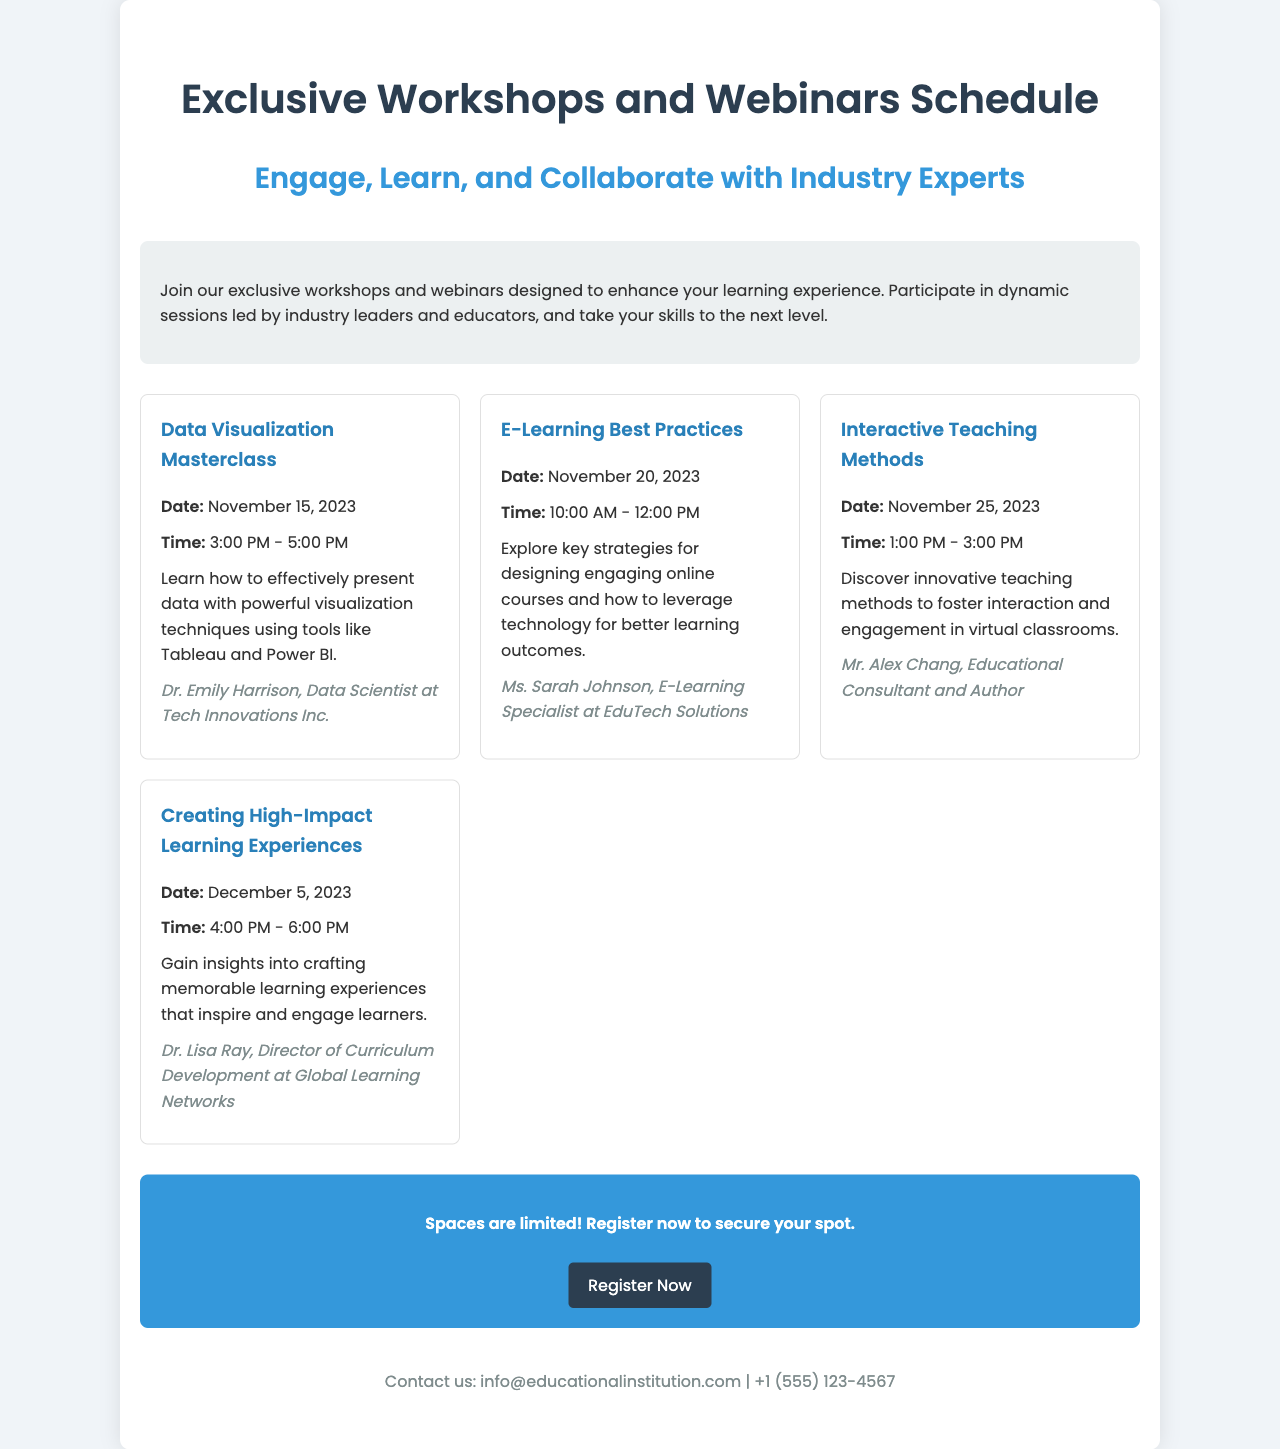What is the title of the brochure? The title of the brochure is prominently displayed at the top of the document, introducing the main content.
Answer: Exclusive Workshops and Webinars Schedule Who is the instructor for the Data Visualization Masterclass? The document includes the name of the instructor for each event, specifically for the Data Visualization Masterclass.
Answer: Dr. Emily Harrison What is the date of the Interactive Teaching Methods workshop? The specific date for each workshop is listed, and for the Interactive Teaching Methods, it is mentioned.
Answer: November 25, 2023 What time does the E-Learning Best Practices webinar start? The schedule provides the starting time for each webinar, particularly for the E-Learning Best Practices event.
Answer: 10:00 AM How many workshops are scheduled in total? By counting the distinct events listed in the schedule, we can determine the total number of workshops.
Answer: Four What is required to secure a spot in the workshops? The registration section emphasizes the need to act quickly to guarantee participation, indicating a demand for prompt registration.
Answer: Register now Which company is Dr. Lisa Ray affiliated with? The document specifies the affiliations of each instructor, particularly mentioning Dr. Lisa Ray's company.
Answer: Global Learning Networks What is the contact email provided in the brochure? The footer includes a contact email for further inquiries regarding the workshops and webinars.
Answer: info@educationalinstitution.com 